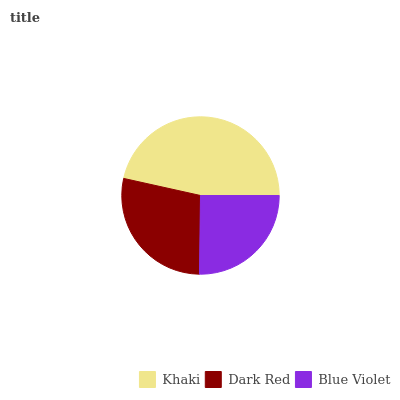Is Blue Violet the minimum?
Answer yes or no. Yes. Is Khaki the maximum?
Answer yes or no. Yes. Is Dark Red the minimum?
Answer yes or no. No. Is Dark Red the maximum?
Answer yes or no. No. Is Khaki greater than Dark Red?
Answer yes or no. Yes. Is Dark Red less than Khaki?
Answer yes or no. Yes. Is Dark Red greater than Khaki?
Answer yes or no. No. Is Khaki less than Dark Red?
Answer yes or no. No. Is Dark Red the high median?
Answer yes or no. Yes. Is Dark Red the low median?
Answer yes or no. Yes. Is Blue Violet the high median?
Answer yes or no. No. Is Blue Violet the low median?
Answer yes or no. No. 